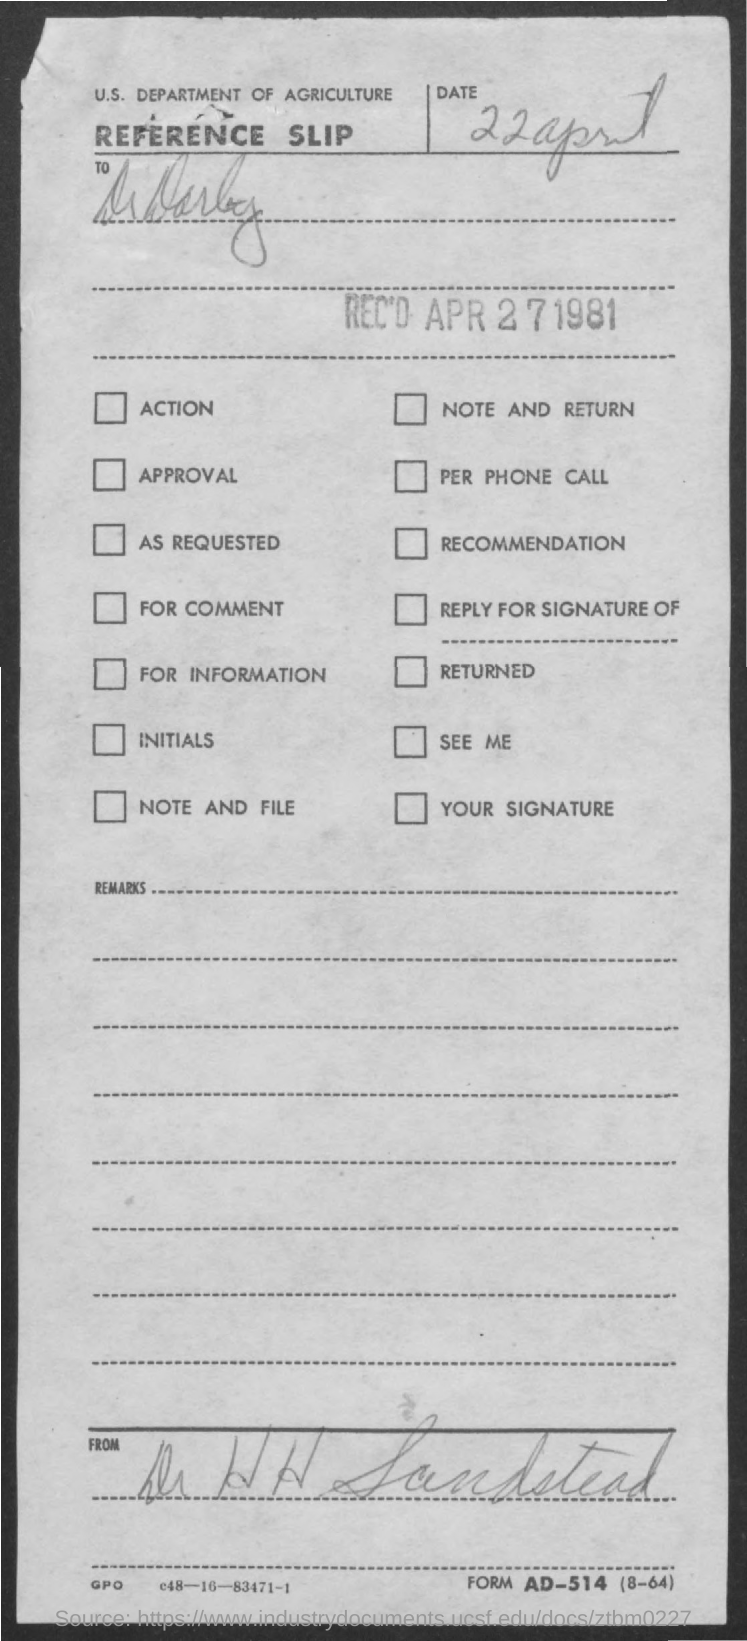List a handful of essential elements in this visual. The department mentioned in the slip is the U.S. Department of Agriculture. The date mentioned in the slip is April 22nd. 